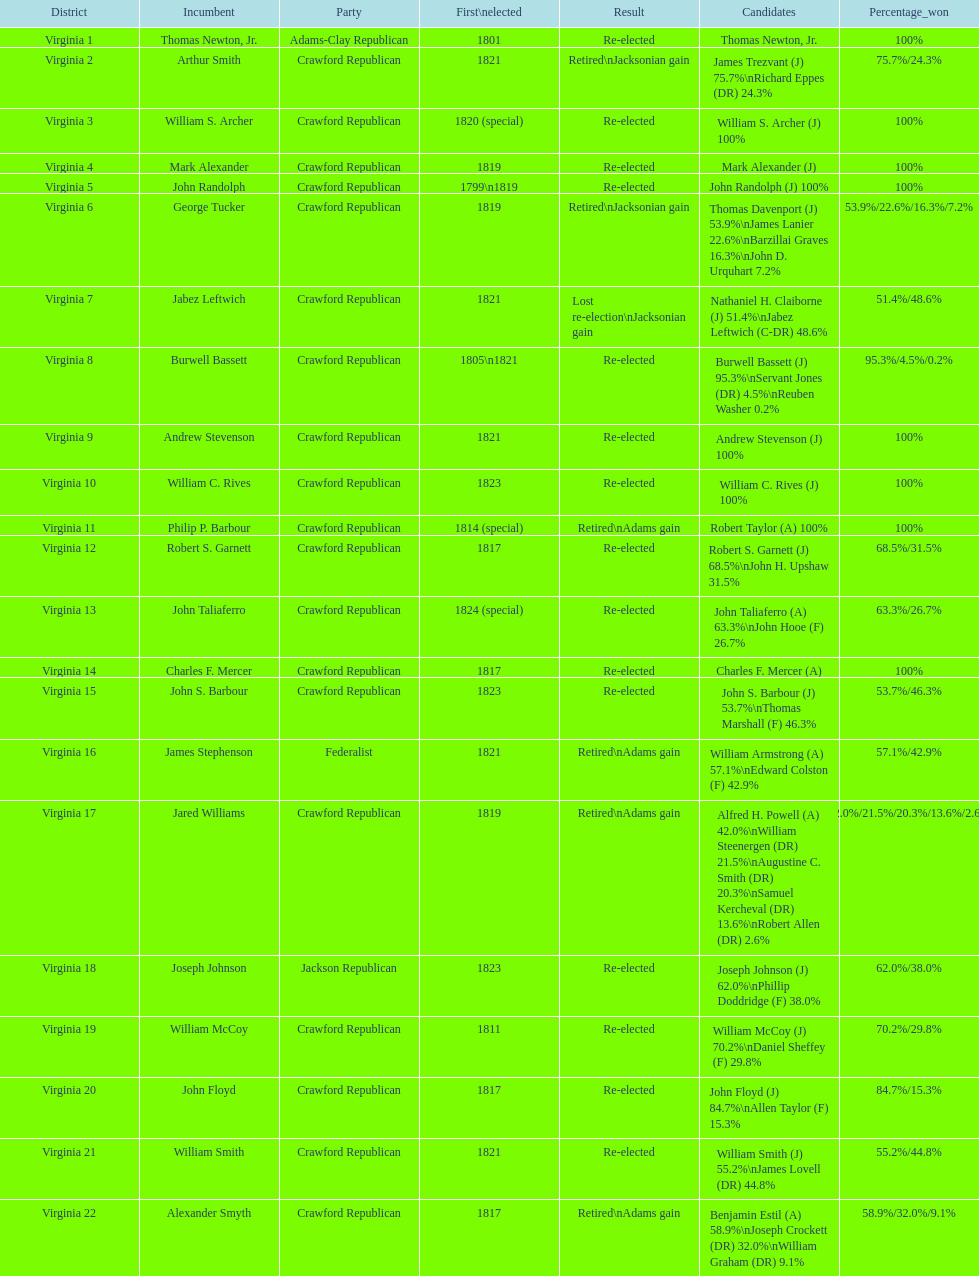Name the only candidate that was first elected in 1811. William McCoy. 